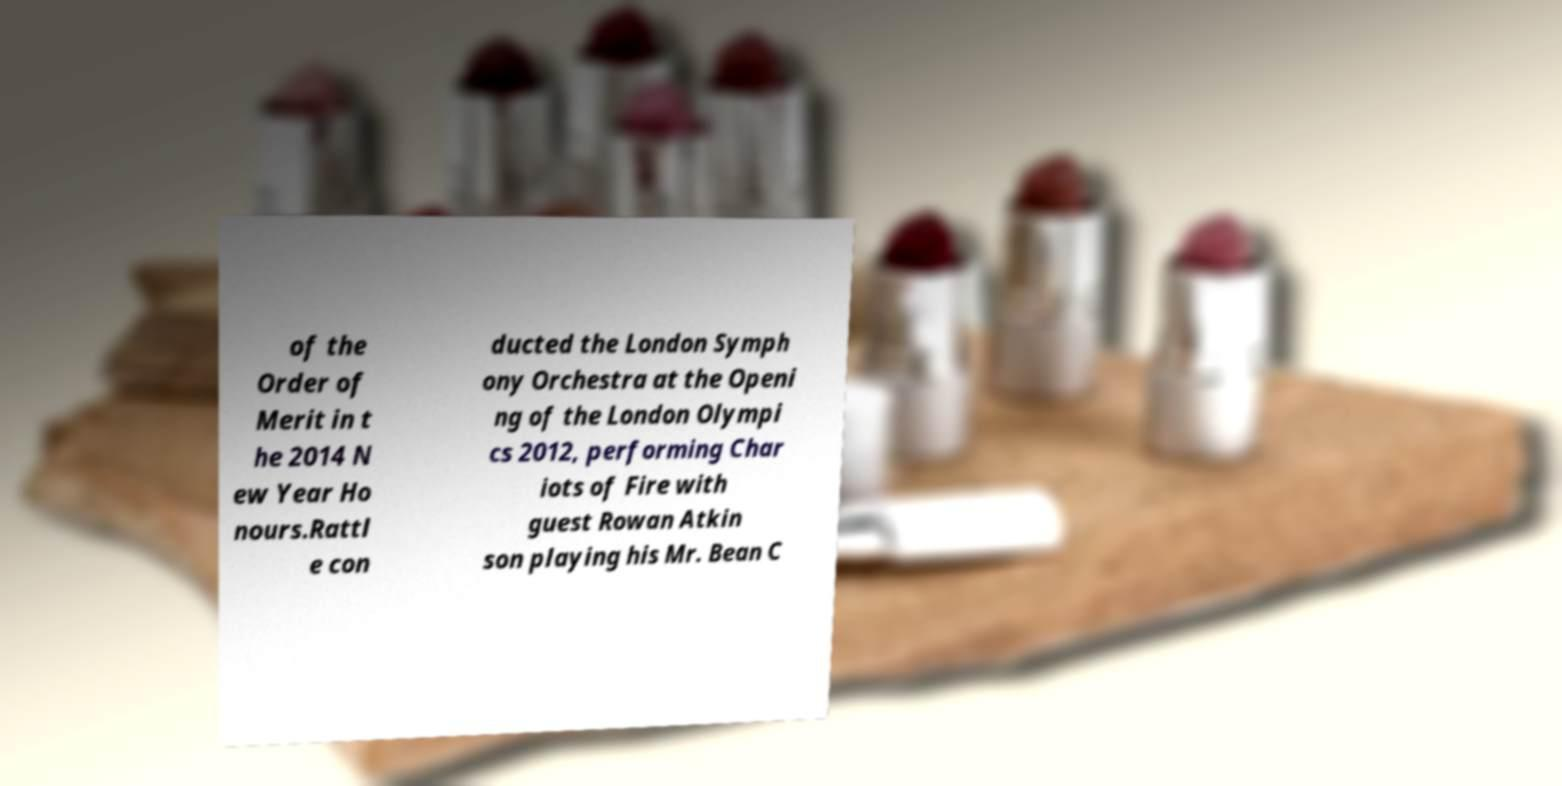What messages or text are displayed in this image? I need them in a readable, typed format. of the Order of Merit in t he 2014 N ew Year Ho nours.Rattl e con ducted the London Symph ony Orchestra at the Openi ng of the London Olympi cs 2012, performing Char iots of Fire with guest Rowan Atkin son playing his Mr. Bean C 